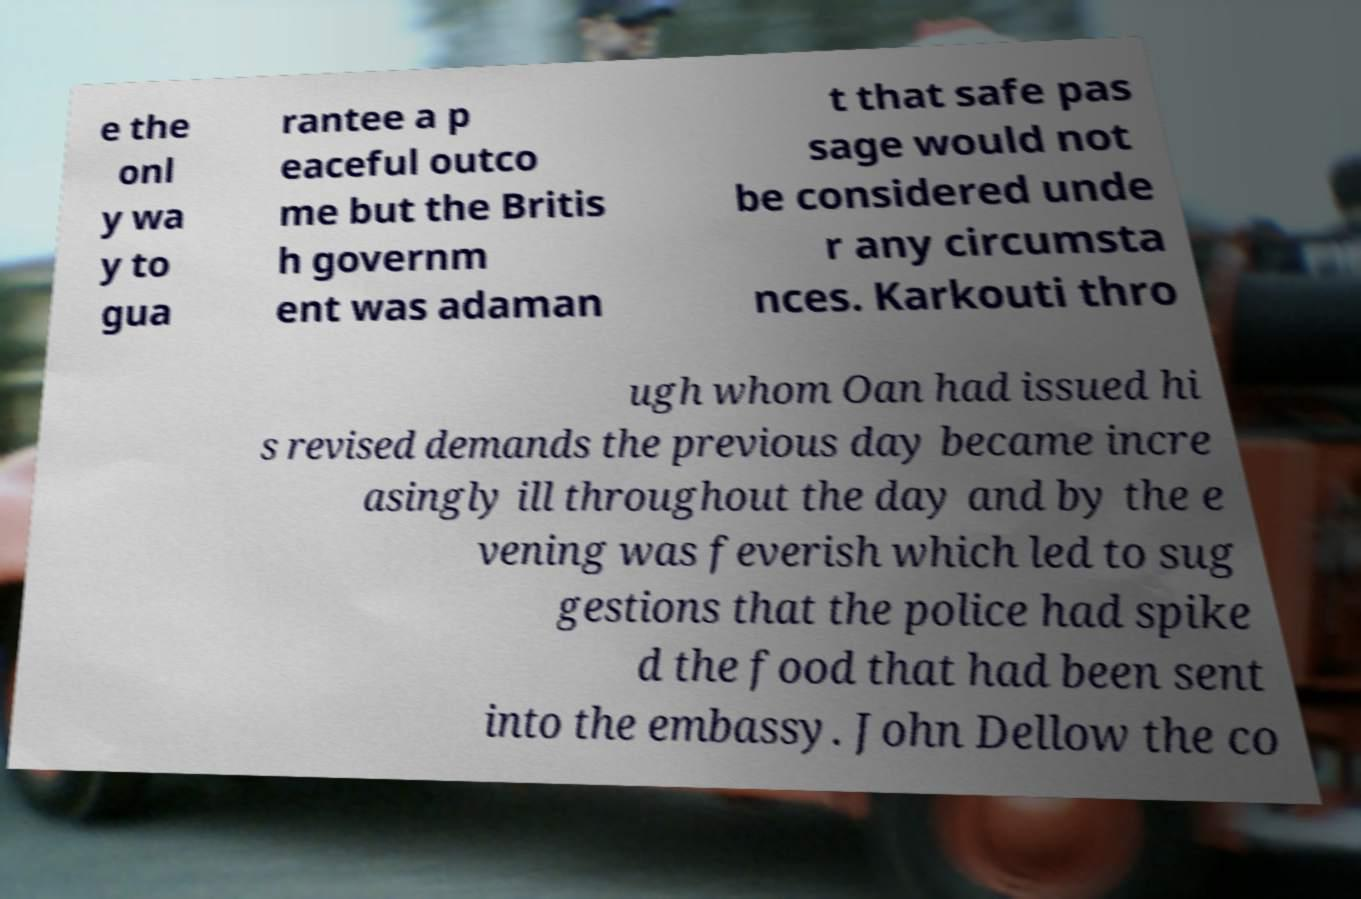Can you read and provide the text displayed in the image?This photo seems to have some interesting text. Can you extract and type it out for me? e the onl y wa y to gua rantee a p eaceful outco me but the Britis h governm ent was adaman t that safe pas sage would not be considered unde r any circumsta nces. Karkouti thro ugh whom Oan had issued hi s revised demands the previous day became incre asingly ill throughout the day and by the e vening was feverish which led to sug gestions that the police had spike d the food that had been sent into the embassy. John Dellow the co 